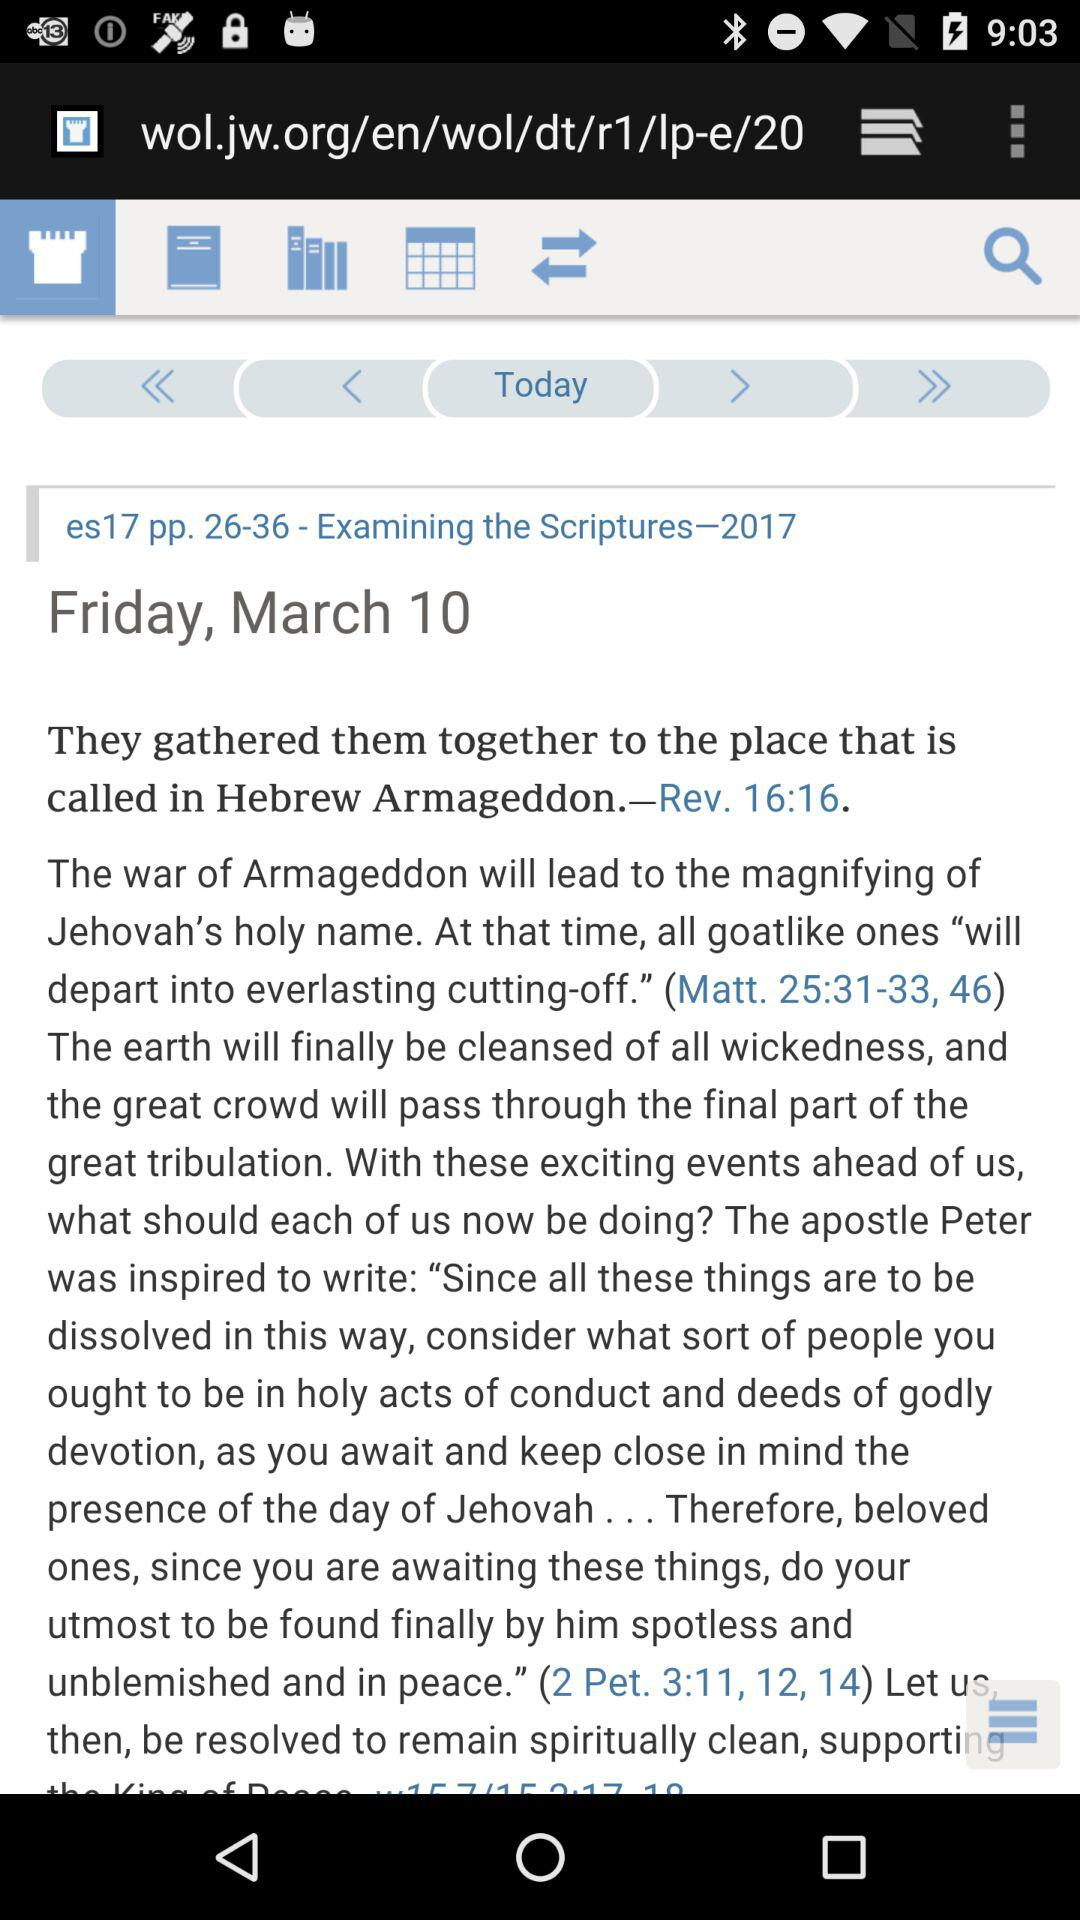What is the year of examining the scriptures? The year is 2017. 